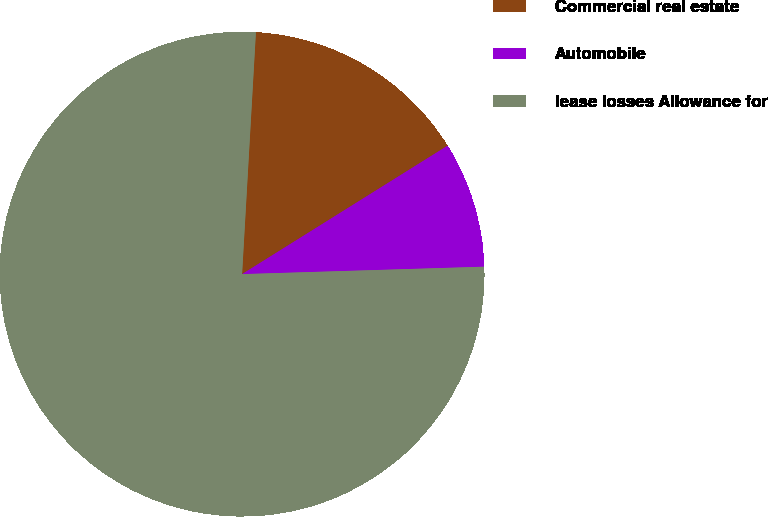Convert chart to OTSL. <chart><loc_0><loc_0><loc_500><loc_500><pie_chart><fcel>Commercial real estate<fcel>Automobile<fcel>lease losses Allowance for<nl><fcel>15.2%<fcel>8.4%<fcel>76.39%<nl></chart> 